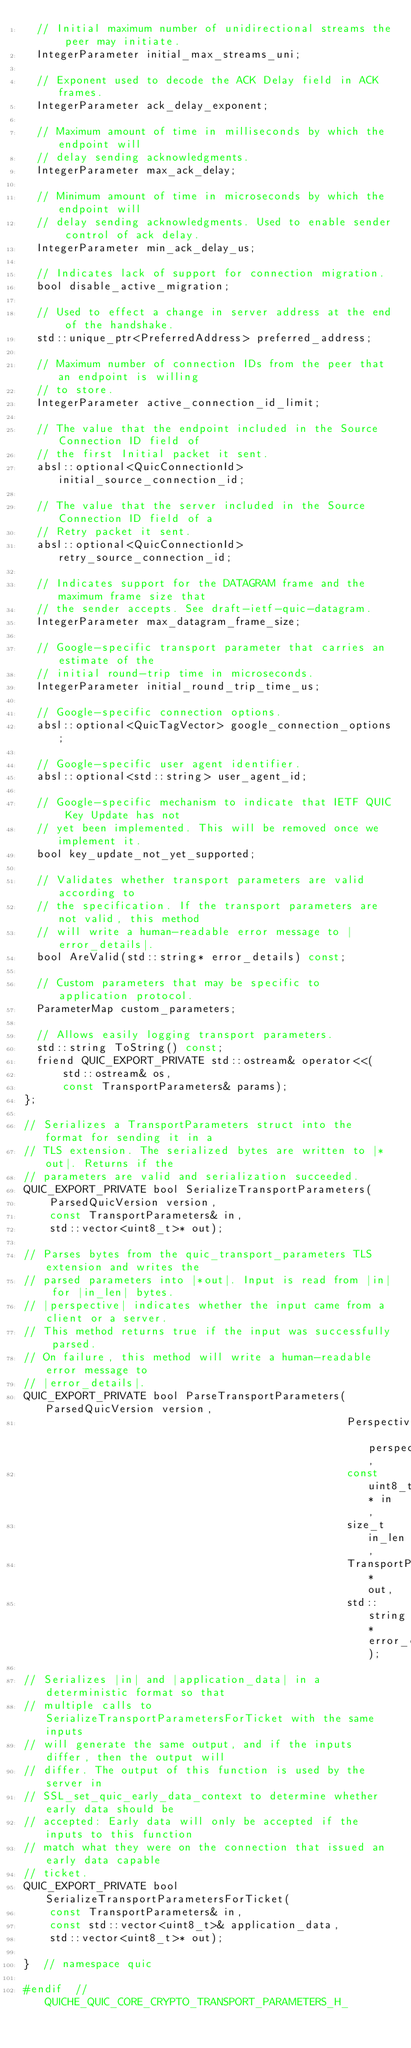<code> <loc_0><loc_0><loc_500><loc_500><_C_>  // Initial maximum number of unidirectional streams the peer may initiate.
  IntegerParameter initial_max_streams_uni;

  // Exponent used to decode the ACK Delay field in ACK frames.
  IntegerParameter ack_delay_exponent;

  // Maximum amount of time in milliseconds by which the endpoint will
  // delay sending acknowledgments.
  IntegerParameter max_ack_delay;

  // Minimum amount of time in microseconds by which the endpoint will
  // delay sending acknowledgments. Used to enable sender control of ack delay.
  IntegerParameter min_ack_delay_us;

  // Indicates lack of support for connection migration.
  bool disable_active_migration;

  // Used to effect a change in server address at the end of the handshake.
  std::unique_ptr<PreferredAddress> preferred_address;

  // Maximum number of connection IDs from the peer that an endpoint is willing
  // to store.
  IntegerParameter active_connection_id_limit;

  // The value that the endpoint included in the Source Connection ID field of
  // the first Initial packet it sent.
  absl::optional<QuicConnectionId> initial_source_connection_id;

  // The value that the server included in the Source Connection ID field of a
  // Retry packet it sent.
  absl::optional<QuicConnectionId> retry_source_connection_id;

  // Indicates support for the DATAGRAM frame and the maximum frame size that
  // the sender accepts. See draft-ietf-quic-datagram.
  IntegerParameter max_datagram_frame_size;

  // Google-specific transport parameter that carries an estimate of the
  // initial round-trip time in microseconds.
  IntegerParameter initial_round_trip_time_us;

  // Google-specific connection options.
  absl::optional<QuicTagVector> google_connection_options;

  // Google-specific user agent identifier.
  absl::optional<std::string> user_agent_id;

  // Google-specific mechanism to indicate that IETF QUIC Key Update has not
  // yet been implemented. This will be removed once we implement it.
  bool key_update_not_yet_supported;

  // Validates whether transport parameters are valid according to
  // the specification. If the transport parameters are not valid, this method
  // will write a human-readable error message to |error_details|.
  bool AreValid(std::string* error_details) const;

  // Custom parameters that may be specific to application protocol.
  ParameterMap custom_parameters;

  // Allows easily logging transport parameters.
  std::string ToString() const;
  friend QUIC_EXPORT_PRIVATE std::ostream& operator<<(
      std::ostream& os,
      const TransportParameters& params);
};

// Serializes a TransportParameters struct into the format for sending it in a
// TLS extension. The serialized bytes are written to |*out|. Returns if the
// parameters are valid and serialization succeeded.
QUIC_EXPORT_PRIVATE bool SerializeTransportParameters(
    ParsedQuicVersion version,
    const TransportParameters& in,
    std::vector<uint8_t>* out);

// Parses bytes from the quic_transport_parameters TLS extension and writes the
// parsed parameters into |*out|. Input is read from |in| for |in_len| bytes.
// |perspective| indicates whether the input came from a client or a server.
// This method returns true if the input was successfully parsed.
// On failure, this method will write a human-readable error message to
// |error_details|.
QUIC_EXPORT_PRIVATE bool ParseTransportParameters(ParsedQuicVersion version,
                                                  Perspective perspective,
                                                  const uint8_t* in,
                                                  size_t in_len,
                                                  TransportParameters* out,
                                                  std::string* error_details);

// Serializes |in| and |application_data| in a deterministic format so that
// multiple calls to SerializeTransportParametersForTicket with the same inputs
// will generate the same output, and if the inputs differ, then the output will
// differ. The output of this function is used by the server in
// SSL_set_quic_early_data_context to determine whether early data should be
// accepted: Early data will only be accepted if the inputs to this function
// match what they were on the connection that issued an early data capable
// ticket.
QUIC_EXPORT_PRIVATE bool SerializeTransportParametersForTicket(
    const TransportParameters& in,
    const std::vector<uint8_t>& application_data,
    std::vector<uint8_t>* out);

}  // namespace quic

#endif  // QUICHE_QUIC_CORE_CRYPTO_TRANSPORT_PARAMETERS_H_
</code> 